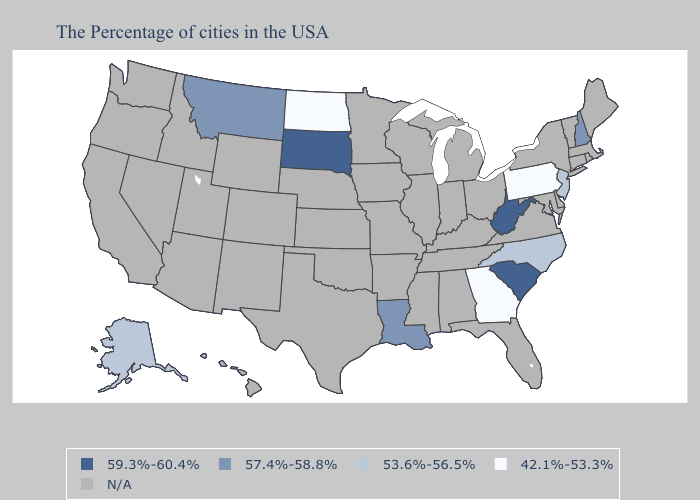Which states hav the highest value in the West?
Short answer required. Montana. Name the states that have a value in the range 53.6%-56.5%?
Give a very brief answer. New Jersey, North Carolina, Alaska. What is the highest value in states that border South Dakota?
Keep it brief. 57.4%-58.8%. Name the states that have a value in the range N/A?
Be succinct. Maine, Massachusetts, Rhode Island, Vermont, Connecticut, New York, Delaware, Maryland, Virginia, Ohio, Florida, Michigan, Kentucky, Indiana, Alabama, Tennessee, Wisconsin, Illinois, Mississippi, Missouri, Arkansas, Minnesota, Iowa, Kansas, Nebraska, Oklahoma, Texas, Wyoming, Colorado, New Mexico, Utah, Arizona, Idaho, Nevada, California, Washington, Oregon, Hawaii. Does the first symbol in the legend represent the smallest category?
Answer briefly. No. Name the states that have a value in the range 59.3%-60.4%?
Quick response, please. South Carolina, West Virginia, South Dakota. What is the lowest value in the South?
Quick response, please. 42.1%-53.3%. Is the legend a continuous bar?
Give a very brief answer. No. What is the value of Mississippi?
Be succinct. N/A. Name the states that have a value in the range N/A?
Answer briefly. Maine, Massachusetts, Rhode Island, Vermont, Connecticut, New York, Delaware, Maryland, Virginia, Ohio, Florida, Michigan, Kentucky, Indiana, Alabama, Tennessee, Wisconsin, Illinois, Mississippi, Missouri, Arkansas, Minnesota, Iowa, Kansas, Nebraska, Oklahoma, Texas, Wyoming, Colorado, New Mexico, Utah, Arizona, Idaho, Nevada, California, Washington, Oregon, Hawaii. Name the states that have a value in the range N/A?
Keep it brief. Maine, Massachusetts, Rhode Island, Vermont, Connecticut, New York, Delaware, Maryland, Virginia, Ohio, Florida, Michigan, Kentucky, Indiana, Alabama, Tennessee, Wisconsin, Illinois, Mississippi, Missouri, Arkansas, Minnesota, Iowa, Kansas, Nebraska, Oklahoma, Texas, Wyoming, Colorado, New Mexico, Utah, Arizona, Idaho, Nevada, California, Washington, Oregon, Hawaii. What is the highest value in states that border Arkansas?
Answer briefly. 57.4%-58.8%. Does the map have missing data?
Give a very brief answer. Yes. Among the states that border Montana , does North Dakota have the lowest value?
Concise answer only. Yes. What is the lowest value in the MidWest?
Give a very brief answer. 42.1%-53.3%. 